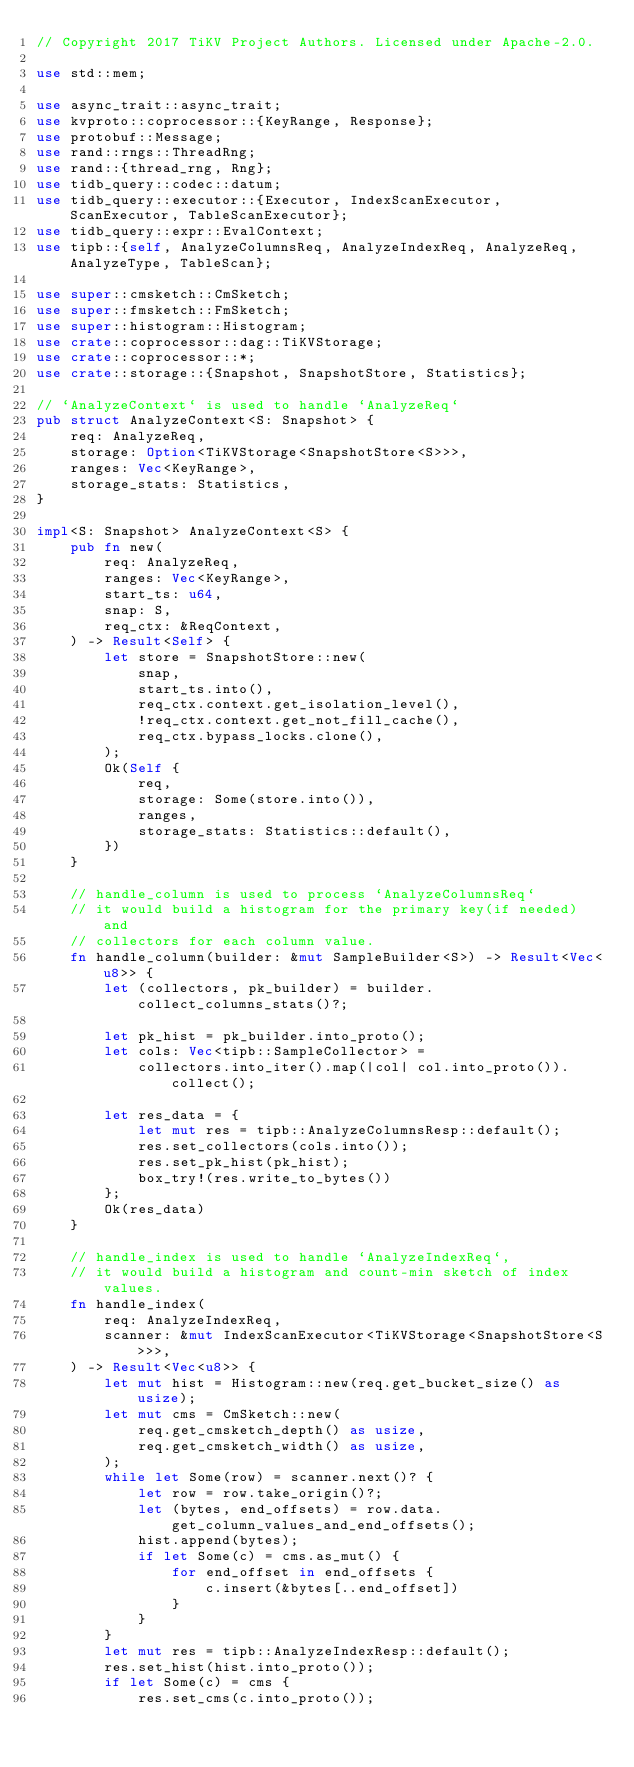Convert code to text. <code><loc_0><loc_0><loc_500><loc_500><_Rust_>// Copyright 2017 TiKV Project Authors. Licensed under Apache-2.0.

use std::mem;

use async_trait::async_trait;
use kvproto::coprocessor::{KeyRange, Response};
use protobuf::Message;
use rand::rngs::ThreadRng;
use rand::{thread_rng, Rng};
use tidb_query::codec::datum;
use tidb_query::executor::{Executor, IndexScanExecutor, ScanExecutor, TableScanExecutor};
use tidb_query::expr::EvalContext;
use tipb::{self, AnalyzeColumnsReq, AnalyzeIndexReq, AnalyzeReq, AnalyzeType, TableScan};

use super::cmsketch::CmSketch;
use super::fmsketch::FmSketch;
use super::histogram::Histogram;
use crate::coprocessor::dag::TiKVStorage;
use crate::coprocessor::*;
use crate::storage::{Snapshot, SnapshotStore, Statistics};

// `AnalyzeContext` is used to handle `AnalyzeReq`
pub struct AnalyzeContext<S: Snapshot> {
    req: AnalyzeReq,
    storage: Option<TiKVStorage<SnapshotStore<S>>>,
    ranges: Vec<KeyRange>,
    storage_stats: Statistics,
}

impl<S: Snapshot> AnalyzeContext<S> {
    pub fn new(
        req: AnalyzeReq,
        ranges: Vec<KeyRange>,
        start_ts: u64,
        snap: S,
        req_ctx: &ReqContext,
    ) -> Result<Self> {
        let store = SnapshotStore::new(
            snap,
            start_ts.into(),
            req_ctx.context.get_isolation_level(),
            !req_ctx.context.get_not_fill_cache(),
            req_ctx.bypass_locks.clone(),
        );
        Ok(Self {
            req,
            storage: Some(store.into()),
            ranges,
            storage_stats: Statistics::default(),
        })
    }

    // handle_column is used to process `AnalyzeColumnsReq`
    // it would build a histogram for the primary key(if needed) and
    // collectors for each column value.
    fn handle_column(builder: &mut SampleBuilder<S>) -> Result<Vec<u8>> {
        let (collectors, pk_builder) = builder.collect_columns_stats()?;

        let pk_hist = pk_builder.into_proto();
        let cols: Vec<tipb::SampleCollector> =
            collectors.into_iter().map(|col| col.into_proto()).collect();

        let res_data = {
            let mut res = tipb::AnalyzeColumnsResp::default();
            res.set_collectors(cols.into());
            res.set_pk_hist(pk_hist);
            box_try!(res.write_to_bytes())
        };
        Ok(res_data)
    }

    // handle_index is used to handle `AnalyzeIndexReq`,
    // it would build a histogram and count-min sketch of index values.
    fn handle_index(
        req: AnalyzeIndexReq,
        scanner: &mut IndexScanExecutor<TiKVStorage<SnapshotStore<S>>>,
    ) -> Result<Vec<u8>> {
        let mut hist = Histogram::new(req.get_bucket_size() as usize);
        let mut cms = CmSketch::new(
            req.get_cmsketch_depth() as usize,
            req.get_cmsketch_width() as usize,
        );
        while let Some(row) = scanner.next()? {
            let row = row.take_origin()?;
            let (bytes, end_offsets) = row.data.get_column_values_and_end_offsets();
            hist.append(bytes);
            if let Some(c) = cms.as_mut() {
                for end_offset in end_offsets {
                    c.insert(&bytes[..end_offset])
                }
            }
        }
        let mut res = tipb::AnalyzeIndexResp::default();
        res.set_hist(hist.into_proto());
        if let Some(c) = cms {
            res.set_cms(c.into_proto());</code> 